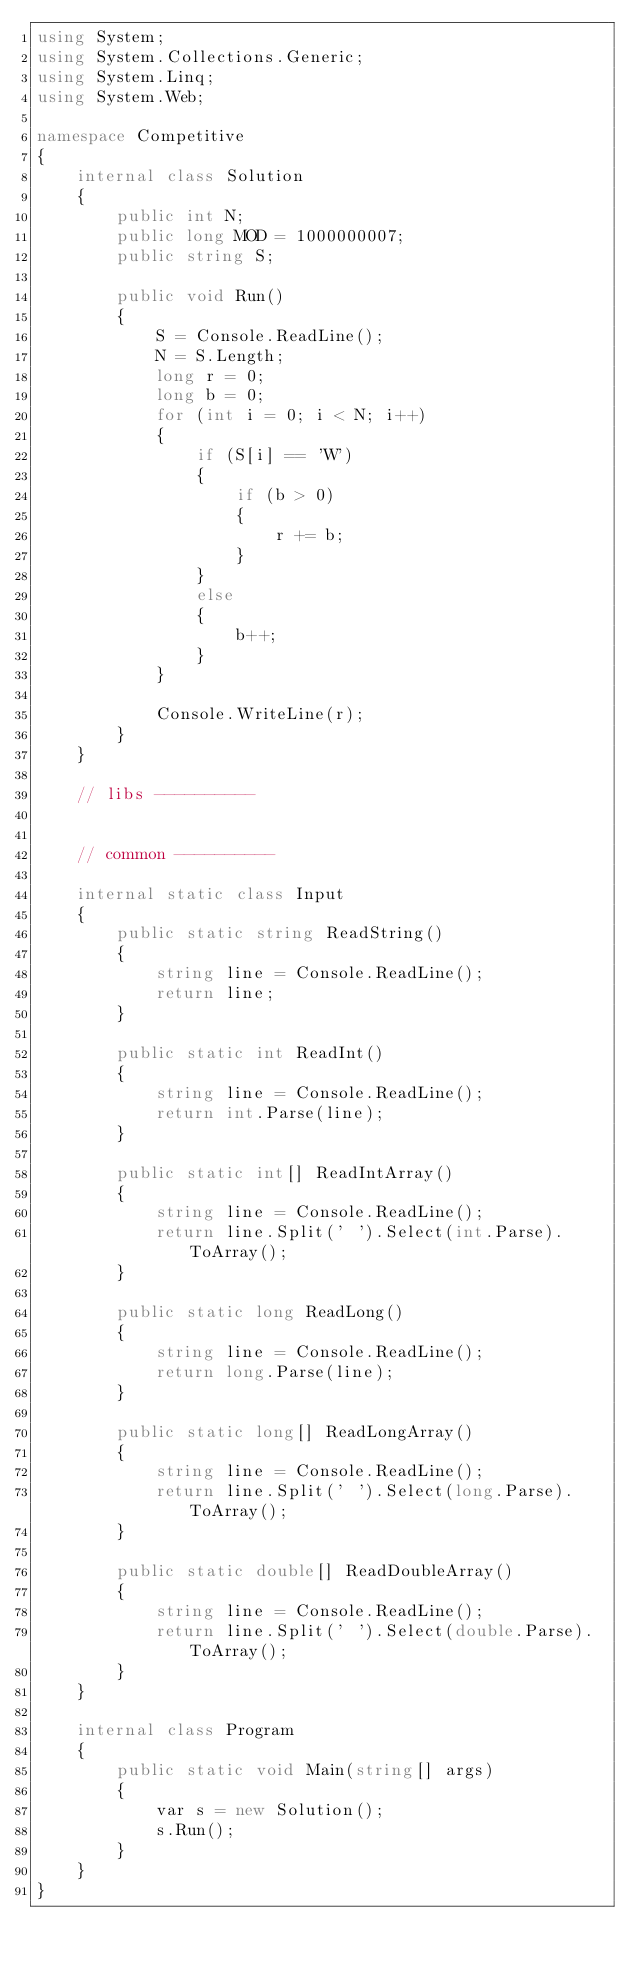Convert code to text. <code><loc_0><loc_0><loc_500><loc_500><_C#_>using System;
using System.Collections.Generic;
using System.Linq;
using System.Web;

namespace Competitive
{
    internal class Solution
    {
        public int N;
        public long MOD = 1000000007;
        public string S;

        public void Run()
        {
            S = Console.ReadLine();
            N = S.Length;
            long r = 0;
            long b = 0;
            for (int i = 0; i < N; i++)
            {
                if (S[i] == 'W')
                {
                    if (b > 0)
                    {
                        r += b;
                    }
                }
                else
                {
                    b++;
                }
            }

            Console.WriteLine(r);
        }
    }

    // libs ----------
    

    // common ----------

    internal static class Input
    {
        public static string ReadString()
        {
            string line = Console.ReadLine();
            return line;
        }

        public static int ReadInt()
        {
            string line = Console.ReadLine();
            return int.Parse(line);
        }

        public static int[] ReadIntArray()
        {
            string line = Console.ReadLine();
            return line.Split(' ').Select(int.Parse).ToArray();            
        }

        public static long ReadLong()
        {
            string line = Console.ReadLine();
            return long.Parse(line);
        }

        public static long[] ReadLongArray()
        {
            string line = Console.ReadLine();
            return line.Split(' ').Select(long.Parse).ToArray();
        }

        public static double[] ReadDoubleArray()
        {
            string line = Console.ReadLine();
            return line.Split(' ').Select(double.Parse).ToArray();
        }
    }
    
    internal class Program
    {
        public static void Main(string[] args)
        {
            var s = new Solution();
            s.Run();
        }
    }
}</code> 